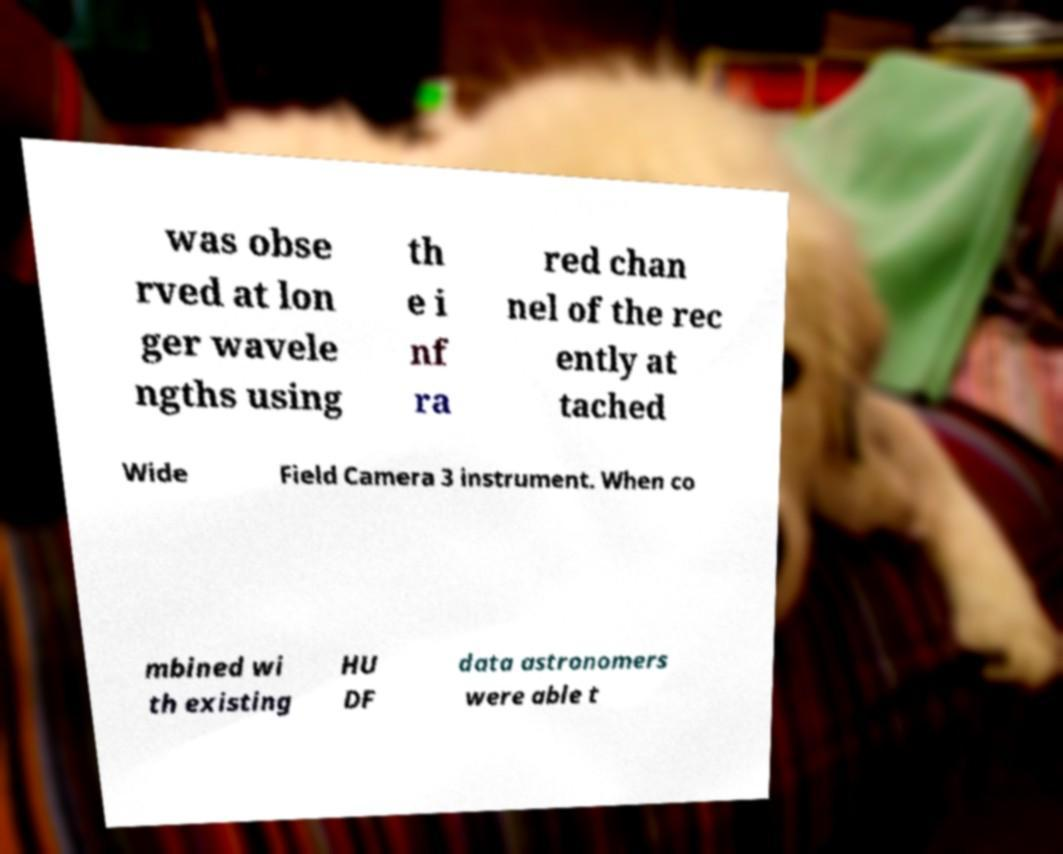I need the written content from this picture converted into text. Can you do that? was obse rved at lon ger wavele ngths using th e i nf ra red chan nel of the rec ently at tached Wide Field Camera 3 instrument. When co mbined wi th existing HU DF data astronomers were able t 